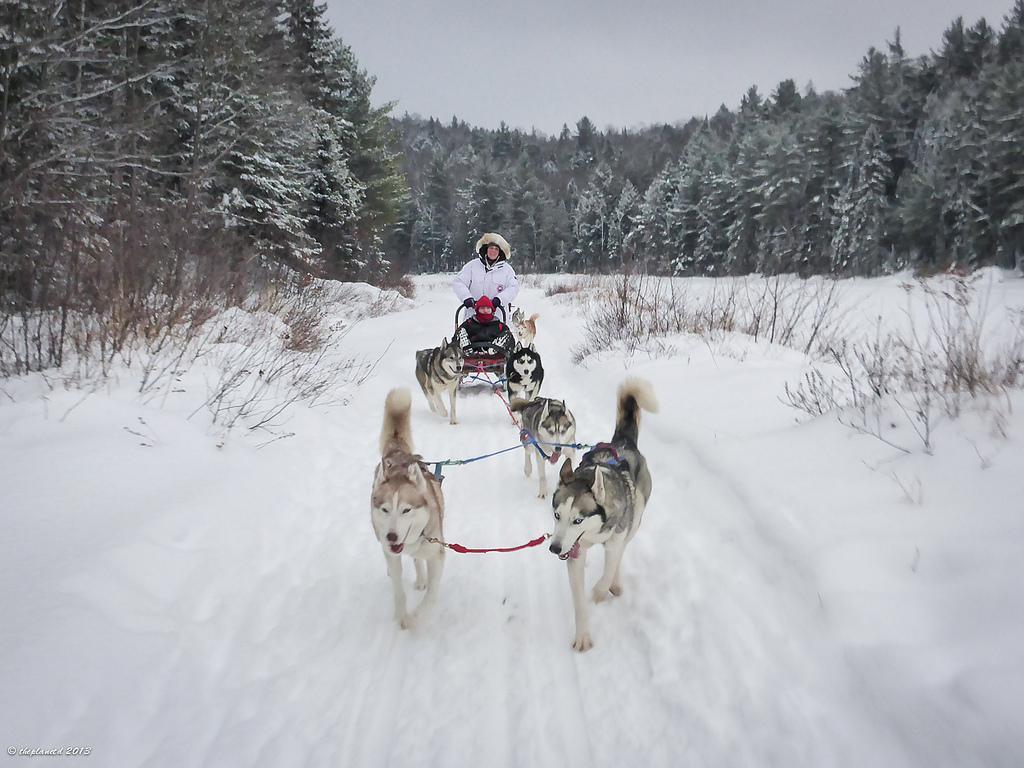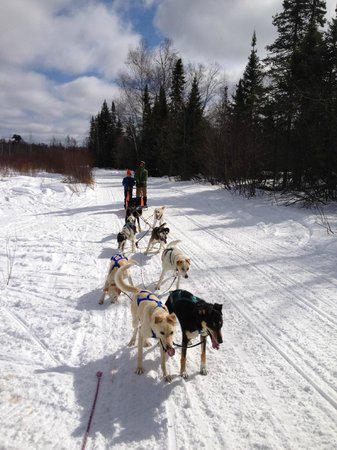The first image is the image on the left, the second image is the image on the right. Analyze the images presented: Is the assertion "At least one of the sleds is empty." valid? Answer yes or no. No. The first image is the image on the left, the second image is the image on the right. For the images shown, is this caption "In one image, mountains form the backdrop to the sled dog team." true? Answer yes or no. No. 